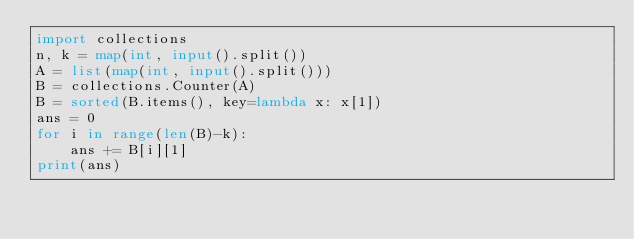Convert code to text. <code><loc_0><loc_0><loc_500><loc_500><_Python_>import collections
n, k = map(int, input().split())
A = list(map(int, input().split()))
B = collections.Counter(A)
B = sorted(B.items(), key=lambda x: x[1])
ans = 0
for i in range(len(B)-k):
    ans += B[i][1]
print(ans)</code> 